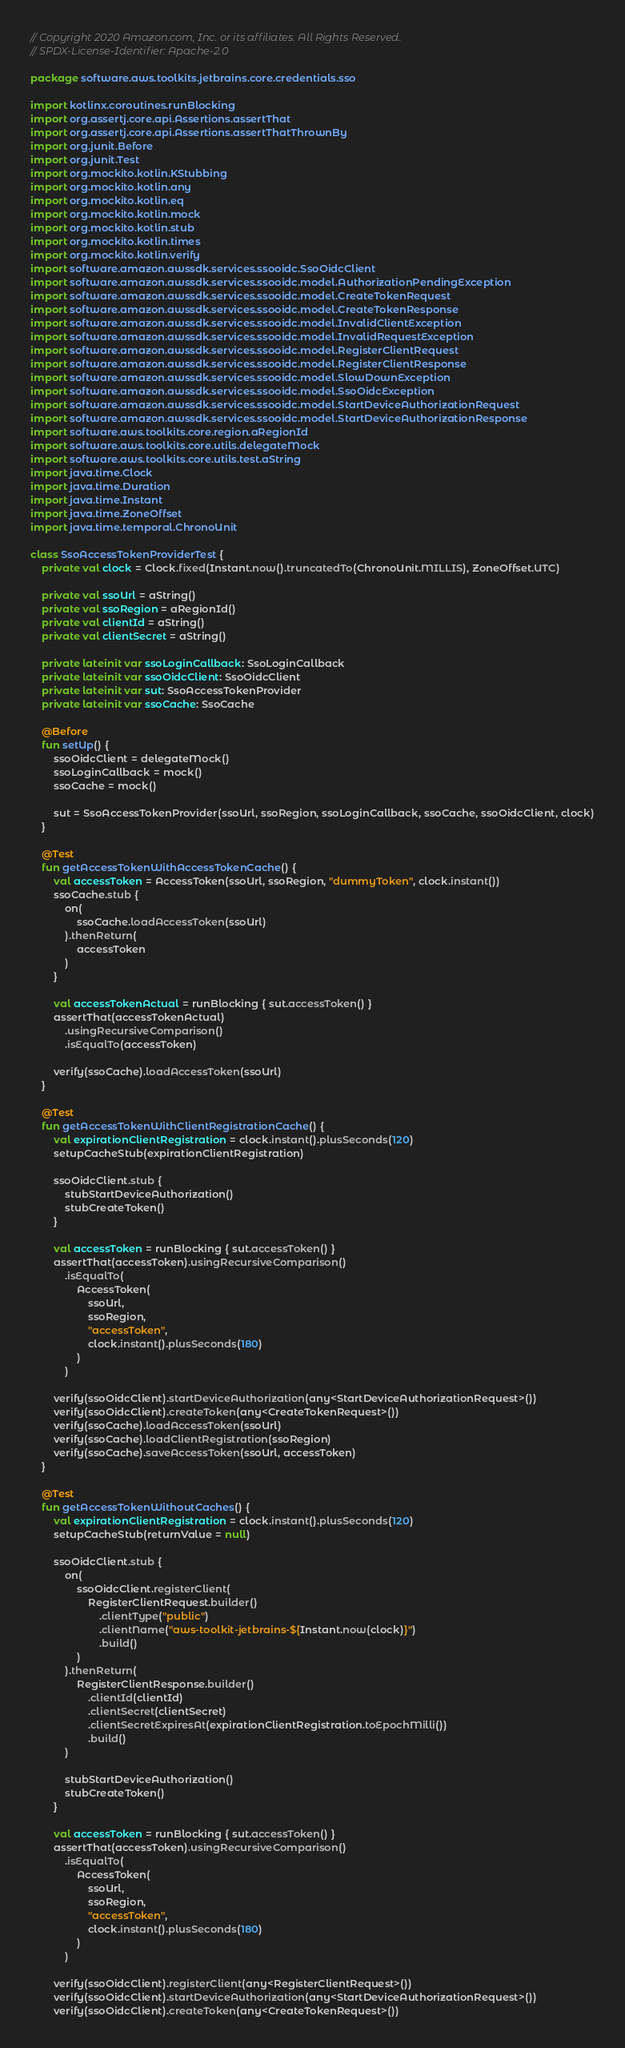Convert code to text. <code><loc_0><loc_0><loc_500><loc_500><_Kotlin_>// Copyright 2020 Amazon.com, Inc. or its affiliates. All Rights Reserved.
// SPDX-License-Identifier: Apache-2.0

package software.aws.toolkits.jetbrains.core.credentials.sso

import kotlinx.coroutines.runBlocking
import org.assertj.core.api.Assertions.assertThat
import org.assertj.core.api.Assertions.assertThatThrownBy
import org.junit.Before
import org.junit.Test
import org.mockito.kotlin.KStubbing
import org.mockito.kotlin.any
import org.mockito.kotlin.eq
import org.mockito.kotlin.mock
import org.mockito.kotlin.stub
import org.mockito.kotlin.times
import org.mockito.kotlin.verify
import software.amazon.awssdk.services.ssooidc.SsoOidcClient
import software.amazon.awssdk.services.ssooidc.model.AuthorizationPendingException
import software.amazon.awssdk.services.ssooidc.model.CreateTokenRequest
import software.amazon.awssdk.services.ssooidc.model.CreateTokenResponse
import software.amazon.awssdk.services.ssooidc.model.InvalidClientException
import software.amazon.awssdk.services.ssooidc.model.InvalidRequestException
import software.amazon.awssdk.services.ssooidc.model.RegisterClientRequest
import software.amazon.awssdk.services.ssooidc.model.RegisterClientResponse
import software.amazon.awssdk.services.ssooidc.model.SlowDownException
import software.amazon.awssdk.services.ssooidc.model.SsoOidcException
import software.amazon.awssdk.services.ssooidc.model.StartDeviceAuthorizationRequest
import software.amazon.awssdk.services.ssooidc.model.StartDeviceAuthorizationResponse
import software.aws.toolkits.core.region.aRegionId
import software.aws.toolkits.core.utils.delegateMock
import software.aws.toolkits.core.utils.test.aString
import java.time.Clock
import java.time.Duration
import java.time.Instant
import java.time.ZoneOffset
import java.time.temporal.ChronoUnit

class SsoAccessTokenProviderTest {
    private val clock = Clock.fixed(Instant.now().truncatedTo(ChronoUnit.MILLIS), ZoneOffset.UTC)

    private val ssoUrl = aString()
    private val ssoRegion = aRegionId()
    private val clientId = aString()
    private val clientSecret = aString()

    private lateinit var ssoLoginCallback: SsoLoginCallback
    private lateinit var ssoOidcClient: SsoOidcClient
    private lateinit var sut: SsoAccessTokenProvider
    private lateinit var ssoCache: SsoCache

    @Before
    fun setUp() {
        ssoOidcClient = delegateMock()
        ssoLoginCallback = mock()
        ssoCache = mock()

        sut = SsoAccessTokenProvider(ssoUrl, ssoRegion, ssoLoginCallback, ssoCache, ssoOidcClient, clock)
    }

    @Test
    fun getAccessTokenWithAccessTokenCache() {
        val accessToken = AccessToken(ssoUrl, ssoRegion, "dummyToken", clock.instant())
        ssoCache.stub {
            on(
                ssoCache.loadAccessToken(ssoUrl)
            ).thenReturn(
                accessToken
            )
        }

        val accessTokenActual = runBlocking { sut.accessToken() }
        assertThat(accessTokenActual)
            .usingRecursiveComparison()
            .isEqualTo(accessToken)

        verify(ssoCache).loadAccessToken(ssoUrl)
    }

    @Test
    fun getAccessTokenWithClientRegistrationCache() {
        val expirationClientRegistration = clock.instant().plusSeconds(120)
        setupCacheStub(expirationClientRegistration)

        ssoOidcClient.stub {
            stubStartDeviceAuthorization()
            stubCreateToken()
        }

        val accessToken = runBlocking { sut.accessToken() }
        assertThat(accessToken).usingRecursiveComparison()
            .isEqualTo(
                AccessToken(
                    ssoUrl,
                    ssoRegion,
                    "accessToken",
                    clock.instant().plusSeconds(180)
                )
            )

        verify(ssoOidcClient).startDeviceAuthorization(any<StartDeviceAuthorizationRequest>())
        verify(ssoOidcClient).createToken(any<CreateTokenRequest>())
        verify(ssoCache).loadAccessToken(ssoUrl)
        verify(ssoCache).loadClientRegistration(ssoRegion)
        verify(ssoCache).saveAccessToken(ssoUrl, accessToken)
    }

    @Test
    fun getAccessTokenWithoutCaches() {
        val expirationClientRegistration = clock.instant().plusSeconds(120)
        setupCacheStub(returnValue = null)

        ssoOidcClient.stub {
            on(
                ssoOidcClient.registerClient(
                    RegisterClientRequest.builder()
                        .clientType("public")
                        .clientName("aws-toolkit-jetbrains-${Instant.now(clock)}")
                        .build()
                )
            ).thenReturn(
                RegisterClientResponse.builder()
                    .clientId(clientId)
                    .clientSecret(clientSecret)
                    .clientSecretExpiresAt(expirationClientRegistration.toEpochMilli())
                    .build()
            )

            stubStartDeviceAuthorization()
            stubCreateToken()
        }

        val accessToken = runBlocking { sut.accessToken() }
        assertThat(accessToken).usingRecursiveComparison()
            .isEqualTo(
                AccessToken(
                    ssoUrl,
                    ssoRegion,
                    "accessToken",
                    clock.instant().plusSeconds(180)
                )
            )

        verify(ssoOidcClient).registerClient(any<RegisterClientRequest>())
        verify(ssoOidcClient).startDeviceAuthorization(any<StartDeviceAuthorizationRequest>())
        verify(ssoOidcClient).createToken(any<CreateTokenRequest>())</code> 